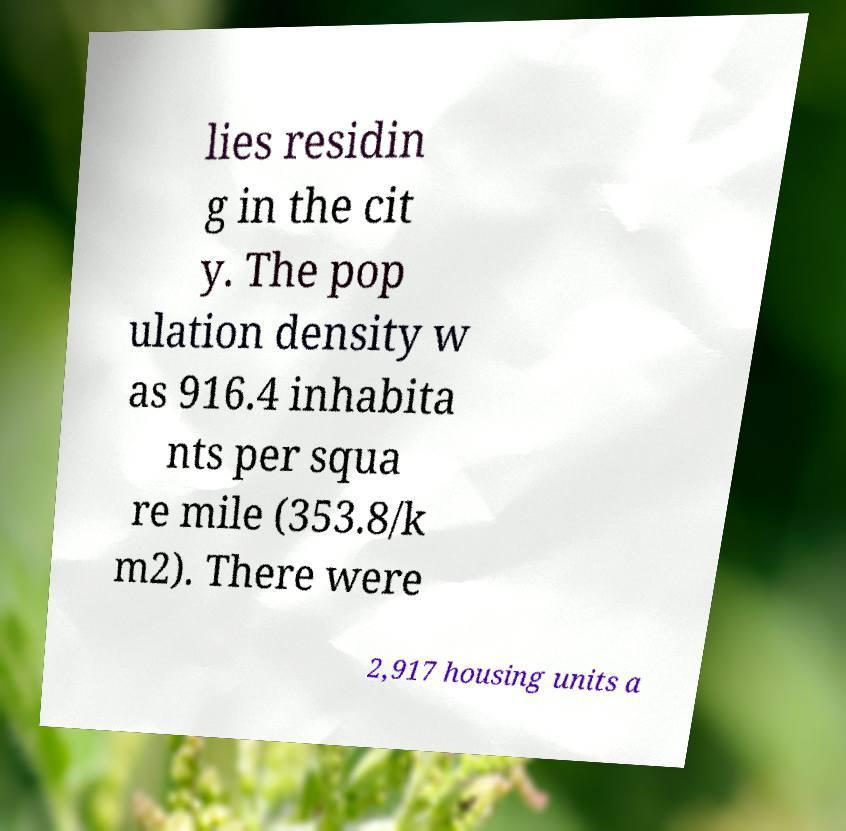What messages or text are displayed in this image? I need them in a readable, typed format. lies residin g in the cit y. The pop ulation density w as 916.4 inhabita nts per squa re mile (353.8/k m2). There were 2,917 housing units a 